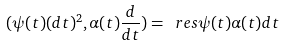<formula> <loc_0><loc_0><loc_500><loc_500>( \psi ( t ) ( d t ) ^ { 2 } , \alpha ( t ) \frac { d } { d t } ) = \ r e s \psi ( t ) \alpha ( t ) d t</formula> 